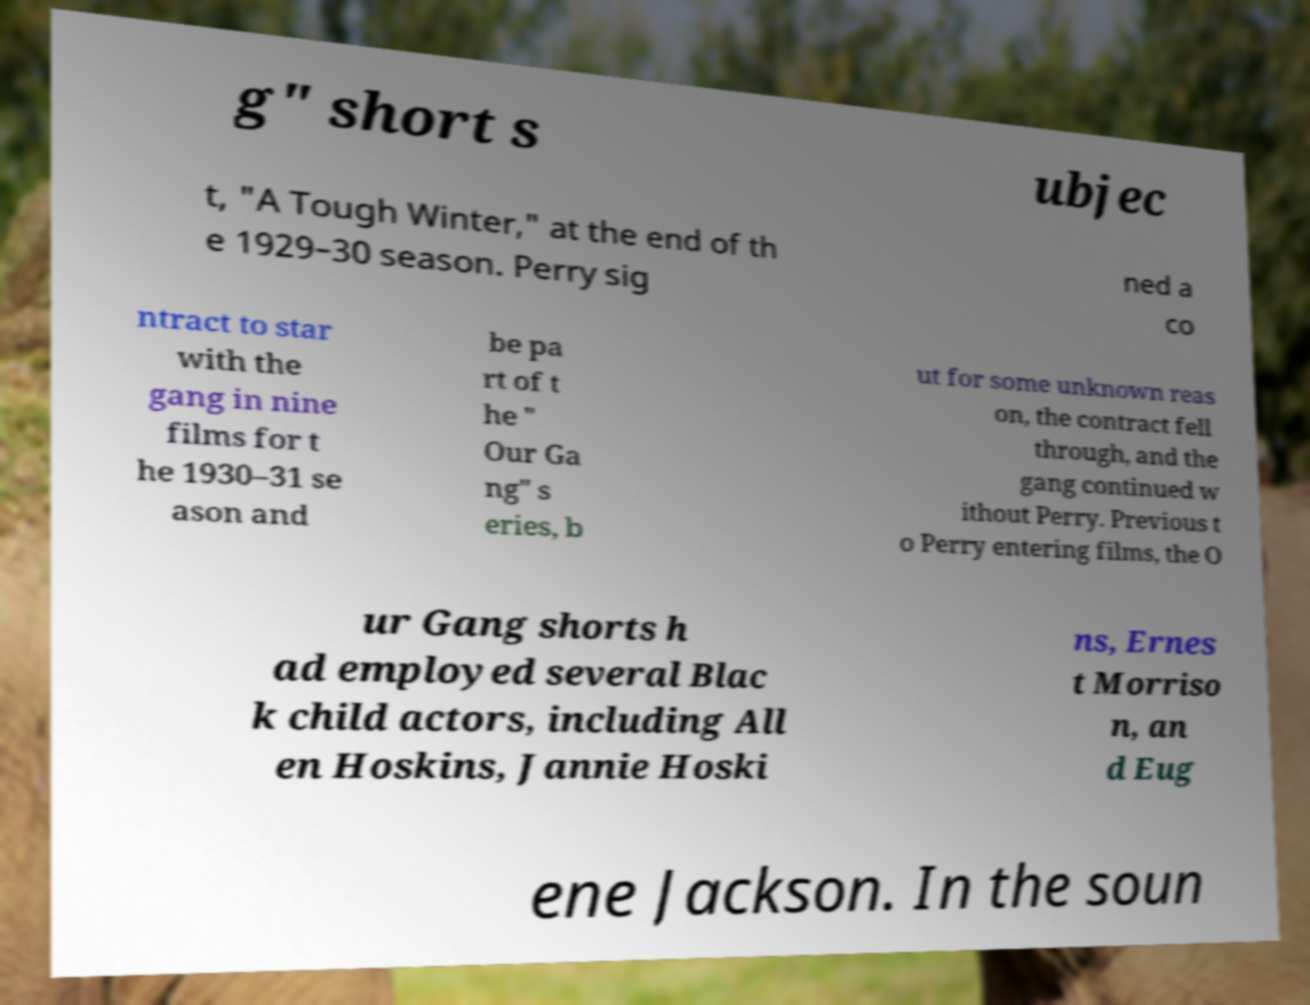I need the written content from this picture converted into text. Can you do that? g" short s ubjec t, "A Tough Winter," at the end of th e 1929–30 season. Perry sig ned a co ntract to star with the gang in nine films for t he 1930–31 se ason and be pa rt of t he " Our Ga ng" s eries, b ut for some unknown reas on, the contract fell through, and the gang continued w ithout Perry. Previous t o Perry entering films, the O ur Gang shorts h ad employed several Blac k child actors, including All en Hoskins, Jannie Hoski ns, Ernes t Morriso n, an d Eug ene Jackson. In the soun 